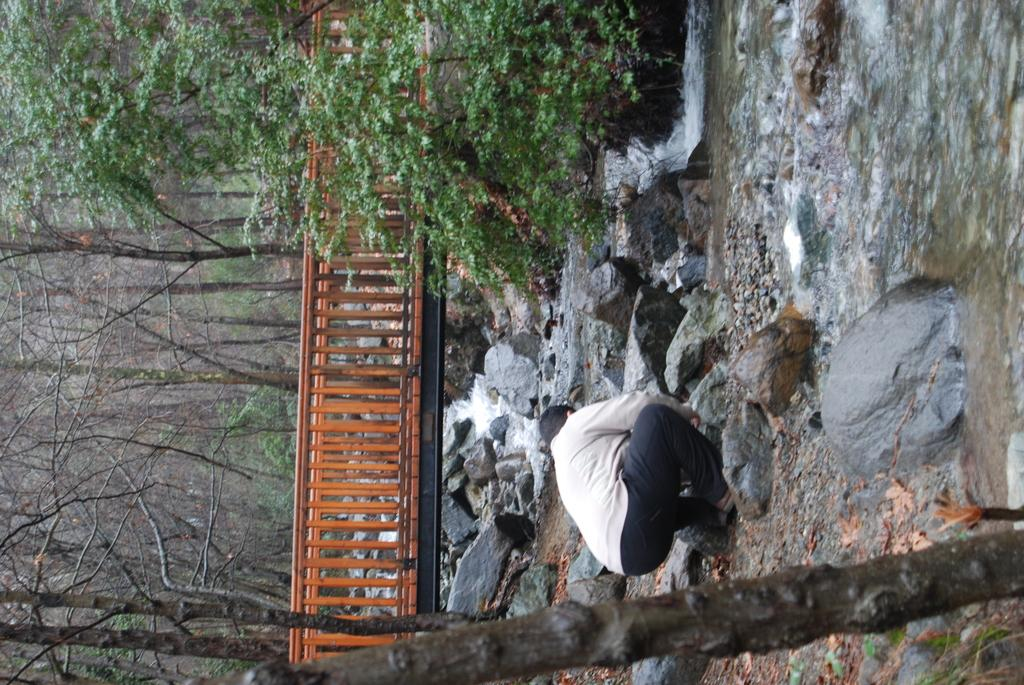What is the person in the image wearing on their upper body? The person is wearing a T-shirt. What type of trousers is the person wearing? The person is wearing black trousers. Where is the person located in the image? The person is on the rocks. What can be seen in the image besides the person? There is water, rocks, a wooden bridge, and trees visible in the image. What is the person's name in the image? The provided facts do not include the person's name, so it cannot be determined from the image. 